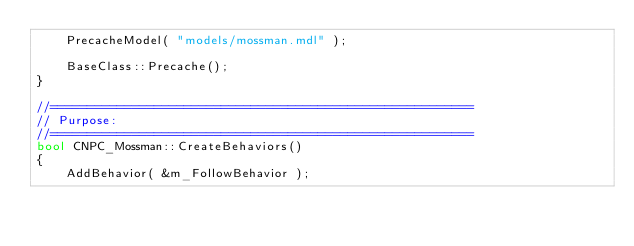<code> <loc_0><loc_0><loc_500><loc_500><_C++_>	PrecacheModel( "models/mossman.mdl" );
	
	BaseClass::Precache();
}	

//=========================================================
// Purpose:
//=========================================================
bool CNPC_Mossman::CreateBehaviors()
{
	AddBehavior( &m_FollowBehavior );
	</code> 